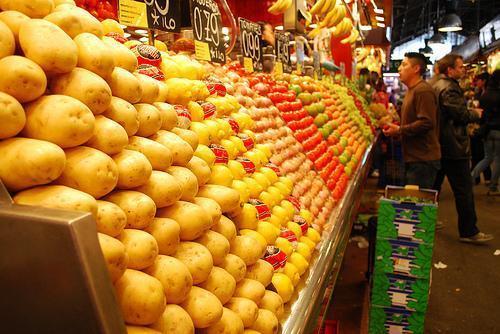How many green crates are there?
Give a very brief answer. 4. How many people in this image are holding fruit and facing left?
Give a very brief answer. 1. 